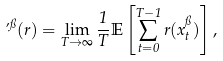Convert formula to latex. <formula><loc_0><loc_0><loc_500><loc_500>\varphi ^ { \pi } ( r ) = \lim _ { T \rightarrow \infty } \frac { 1 } { T } \mathbb { E } \left [ \sum _ { t = 0 } ^ { T - 1 } r ( x _ { t } ^ { \pi } ) \right ] ,</formula> 